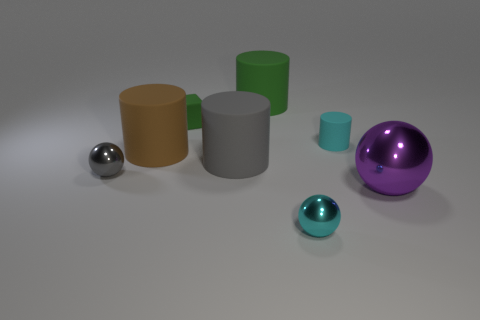How many big purple metallic objects are on the left side of the cylinder that is to the right of the large green matte thing?
Your answer should be very brief. 0. Is the material of the cyan sphere the same as the big brown cylinder?
Make the answer very short. No. What is the size of the cylinder that is the same color as the cube?
Offer a terse response. Large. Is there a large green object made of the same material as the gray cylinder?
Provide a succinct answer. Yes. What is the color of the ball on the right side of the small cyan object that is in front of the tiny ball behind the tiny cyan metallic sphere?
Your answer should be very brief. Purple. What number of green objects are tiny objects or tiny matte objects?
Make the answer very short. 1. What number of other objects are the same shape as the purple thing?
Your answer should be compact. 2. What is the shape of the purple thing that is the same size as the brown rubber thing?
Give a very brief answer. Sphere. Are there any brown cylinders in front of the small cyan rubber cylinder?
Provide a short and direct response. Yes. There is a large purple thing in front of the large brown cylinder; is there a shiny thing in front of it?
Keep it short and to the point. Yes. 